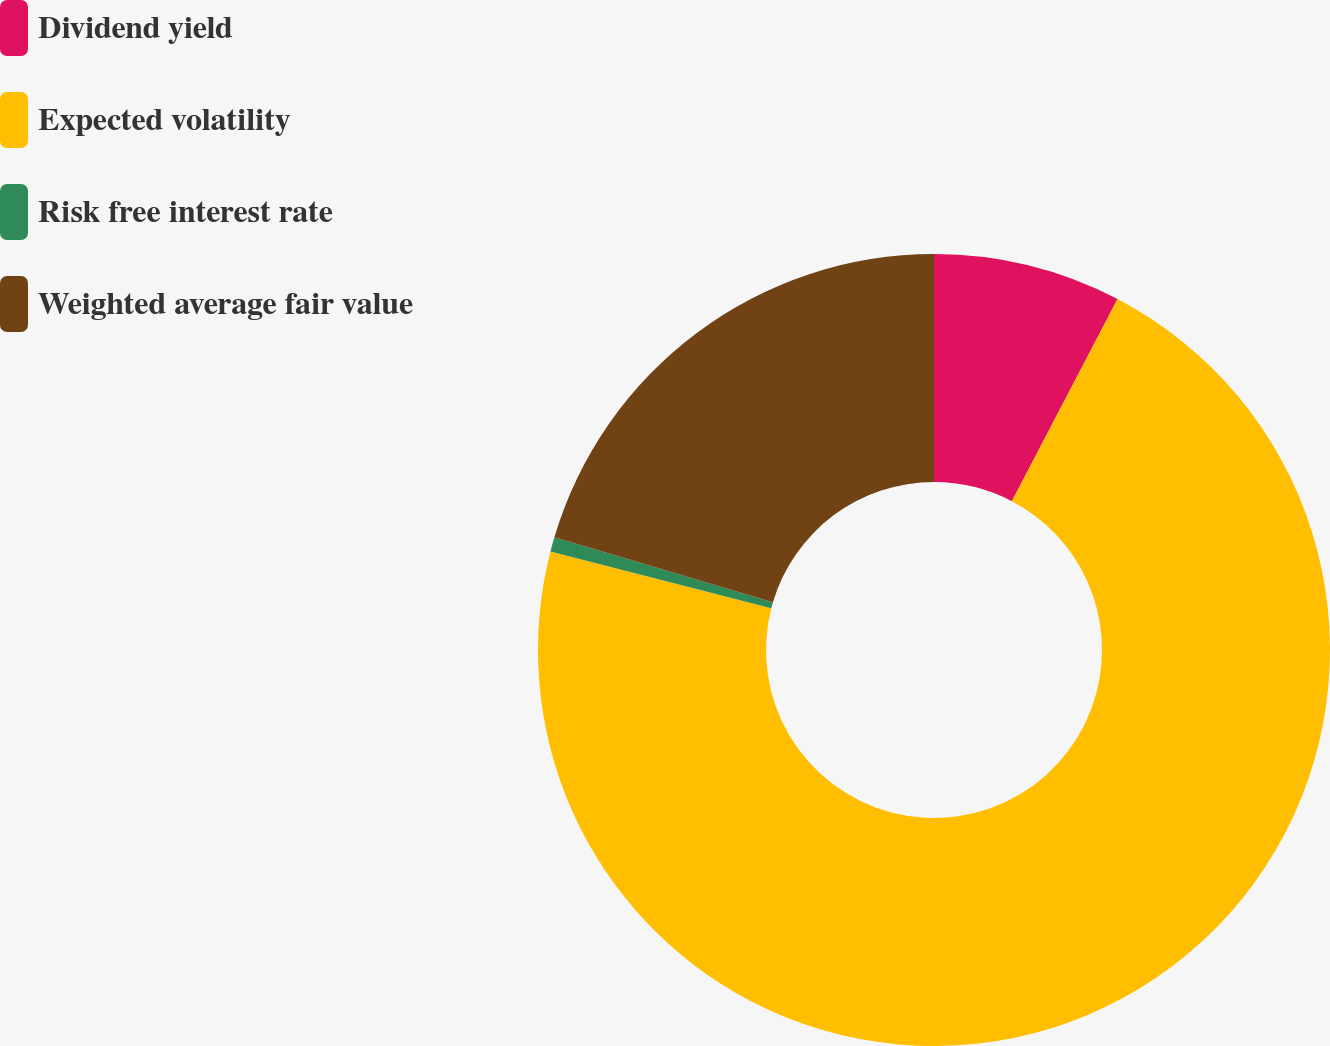Convert chart. <chart><loc_0><loc_0><loc_500><loc_500><pie_chart><fcel>Dividend yield<fcel>Expected volatility<fcel>Risk free interest rate<fcel>Weighted average fair value<nl><fcel>7.67%<fcel>71.33%<fcel>0.59%<fcel>20.41%<nl></chart> 